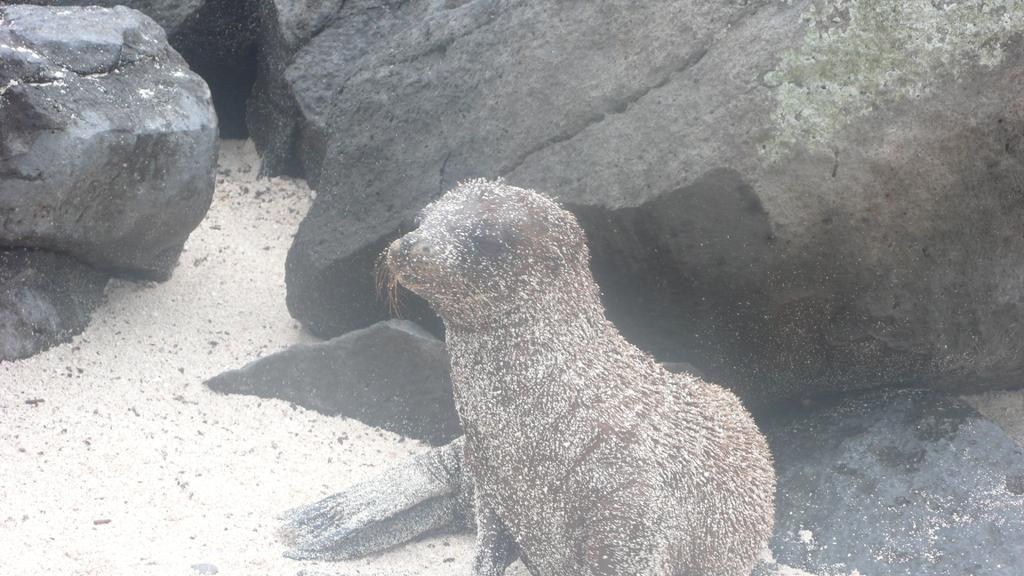What type of animal is in the image? There is a seal in the image. What can be seen in the background of the image? There are rocks in the background of the image. What type of toys can be seen in the image? There are no toys present in the image. What type of eggs can be seen in the image? There are no eggs present in the image. What type of tool is being used by the seal in the image? There is no tool, such as a wrench, present in the image. 